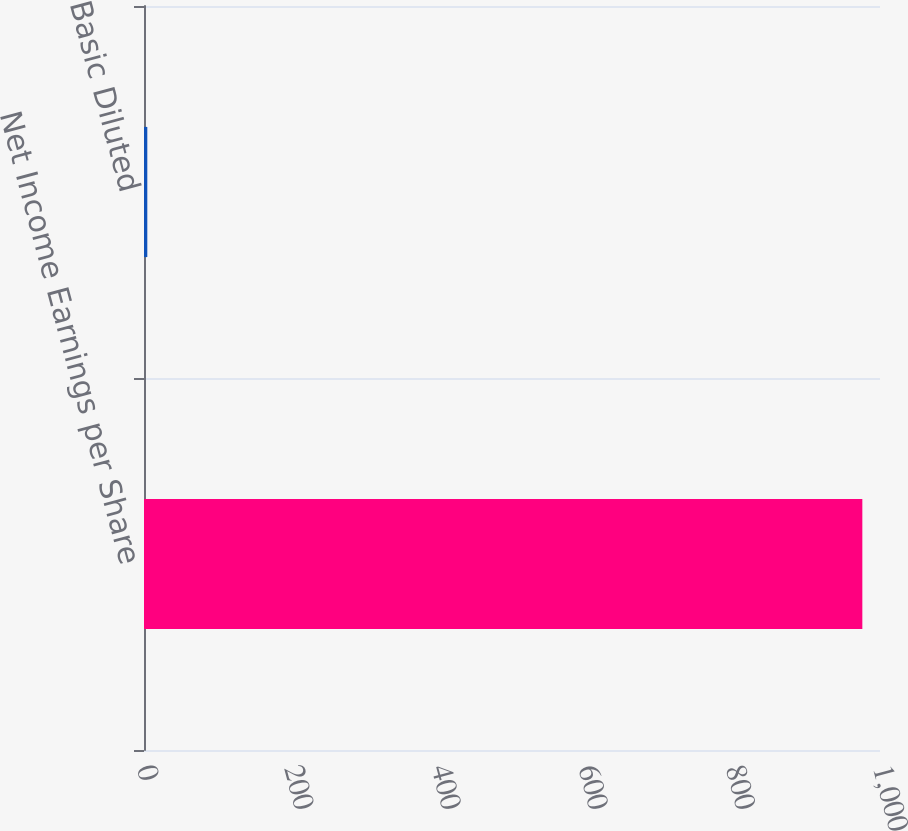<chart> <loc_0><loc_0><loc_500><loc_500><bar_chart><fcel>Net Income Earnings per Share<fcel>Basic Diluted<nl><fcel>976<fcel>4.49<nl></chart> 